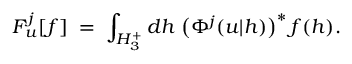<formula> <loc_0><loc_0><loc_500><loc_500>F _ { u } ^ { j } [ f ] \, = \, \int _ { H _ { 3 } ^ { + } } d h \, \left ( \Phi ^ { j } ( u | h ) \right ) ^ { * } \, f ( h ) .</formula> 